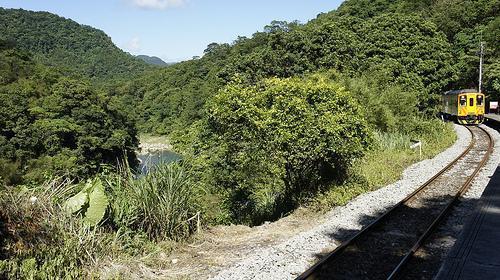How many trains are in this photo?
Give a very brief answer. 1. 